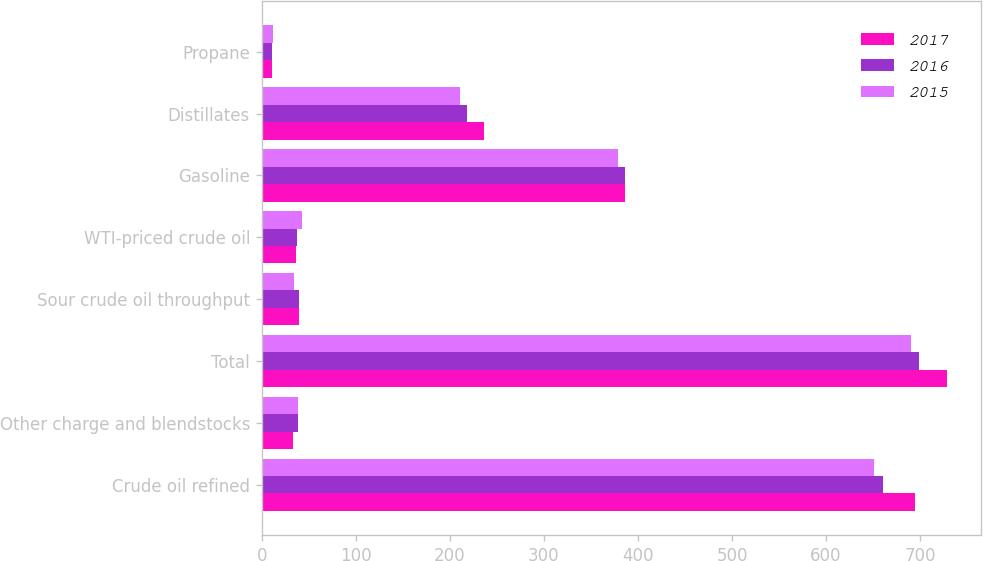Convert chart. <chart><loc_0><loc_0><loc_500><loc_500><stacked_bar_chart><ecel><fcel>Crude oil refined<fcel>Other charge and blendstocks<fcel>Total<fcel>Sour crude oil throughput<fcel>WTI-priced crude oil<fcel>Gasoline<fcel>Distillates<fcel>Propane<nl><fcel>2017<fcel>695<fcel>33<fcel>728<fcel>40<fcel>37<fcel>386<fcel>236<fcel>11<nl><fcel>2016<fcel>660<fcel>39<fcel>699<fcel>40<fcel>38<fcel>386<fcel>218<fcel>11<nl><fcel>2015<fcel>651<fcel>39<fcel>690<fcel>34<fcel>43<fcel>379<fcel>211<fcel>12<nl></chart> 